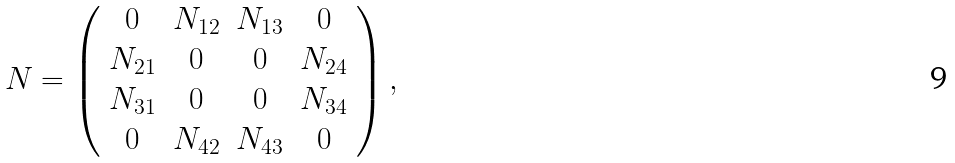<formula> <loc_0><loc_0><loc_500><loc_500>N = \left ( \begin{array} { c c c c } 0 & N _ { 1 2 } & N _ { 1 3 } & 0 \\ N _ { 2 1 } & 0 & 0 & N _ { 2 4 } \\ N _ { 3 1 } & 0 & 0 & N _ { 3 4 } \\ 0 & N _ { 4 2 } & N _ { 4 3 } & 0 \end{array} \right ) ,</formula> 